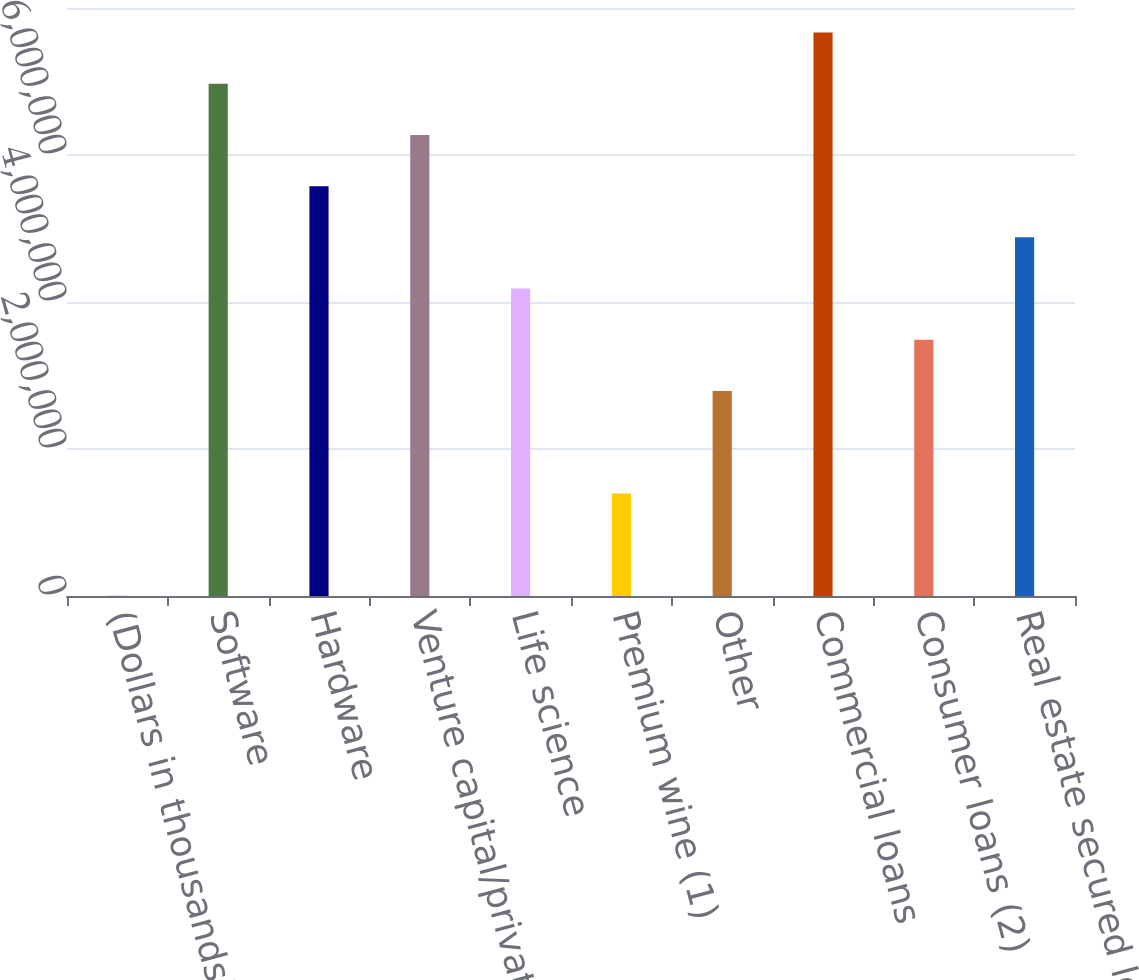<chart> <loc_0><loc_0><loc_500><loc_500><bar_chart><fcel>(Dollars in thousands)<fcel>Software<fcel>Hardware<fcel>Venture capital/private equity<fcel>Life science<fcel>Premium wine (1)<fcel>Other<fcel>Commercial loans<fcel>Consumer loans (2)<fcel>Real estate secured loans<nl><fcel>2011<fcel>6.97008e+06<fcel>5.57647e+06<fcel>6.27327e+06<fcel>4.18285e+06<fcel>1.39563e+06<fcel>2.78924e+06<fcel>7.66689e+06<fcel>3.48605e+06<fcel>4.87966e+06<nl></chart> 